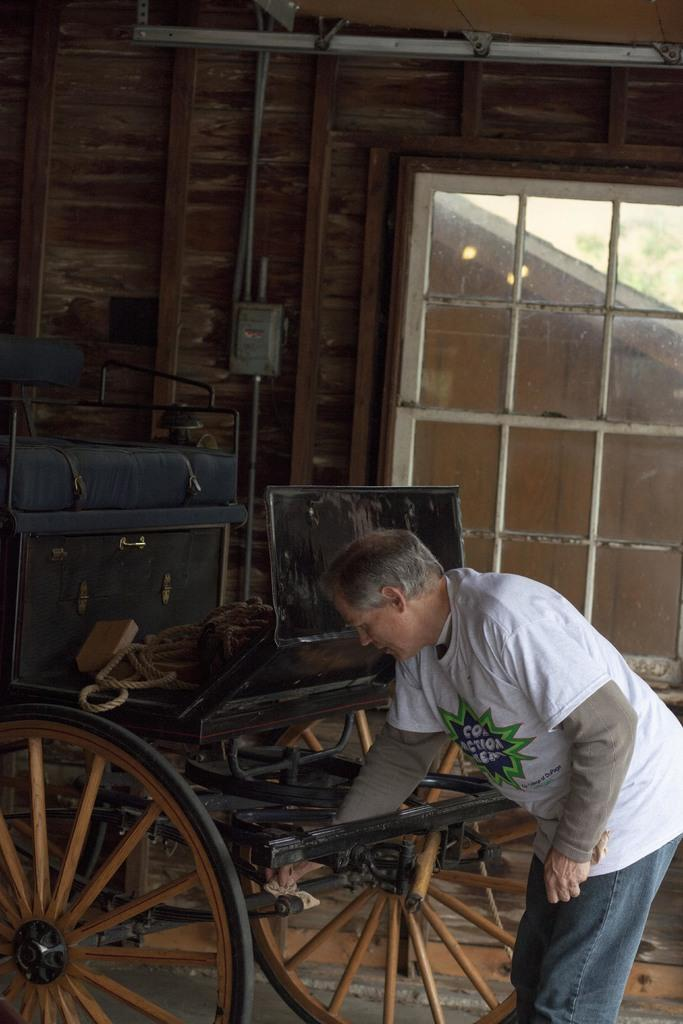Who is present in the image? There is a man in the image. What object can be seen in the image that might be used for transportation? There is a cart in the image. What architectural feature is visible in the image? There is a window and a wall in the image. What is being used to hold or suspend something in the image? There is a rope in the image. What type of illumination is present in the image? There are lights in the image. What other objects can be seen in the image? There are some objects in the image. What can be seen in the background of the image? There are leaves visible in the background of the image. How many frogs are sitting on the watch in the image? There is no watch or frogs present in the image. What type of fruit is hanging from the rope in the image? There is no fruit hanging from the rope in the image. 